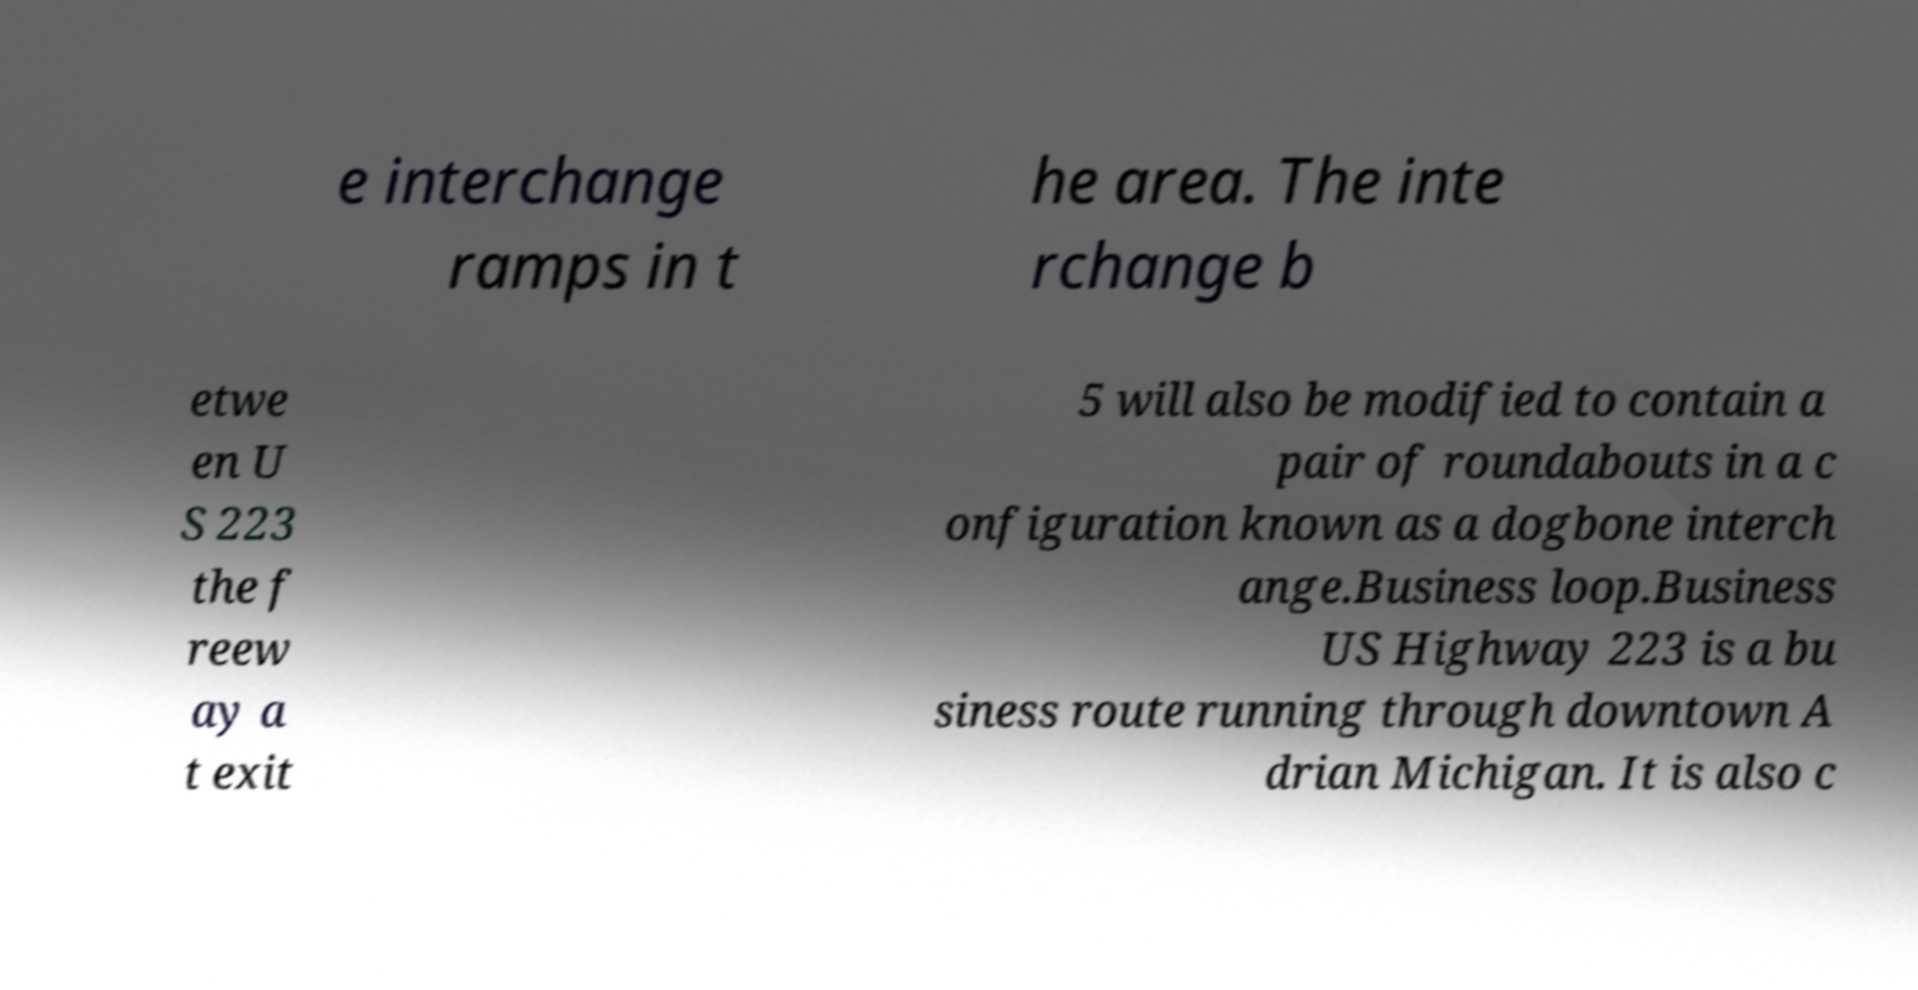I need the written content from this picture converted into text. Can you do that? e interchange ramps in t he area. The inte rchange b etwe en U S 223 the f reew ay a t exit 5 will also be modified to contain a pair of roundabouts in a c onfiguration known as a dogbone interch ange.Business loop.Business US Highway 223 is a bu siness route running through downtown A drian Michigan. It is also c 